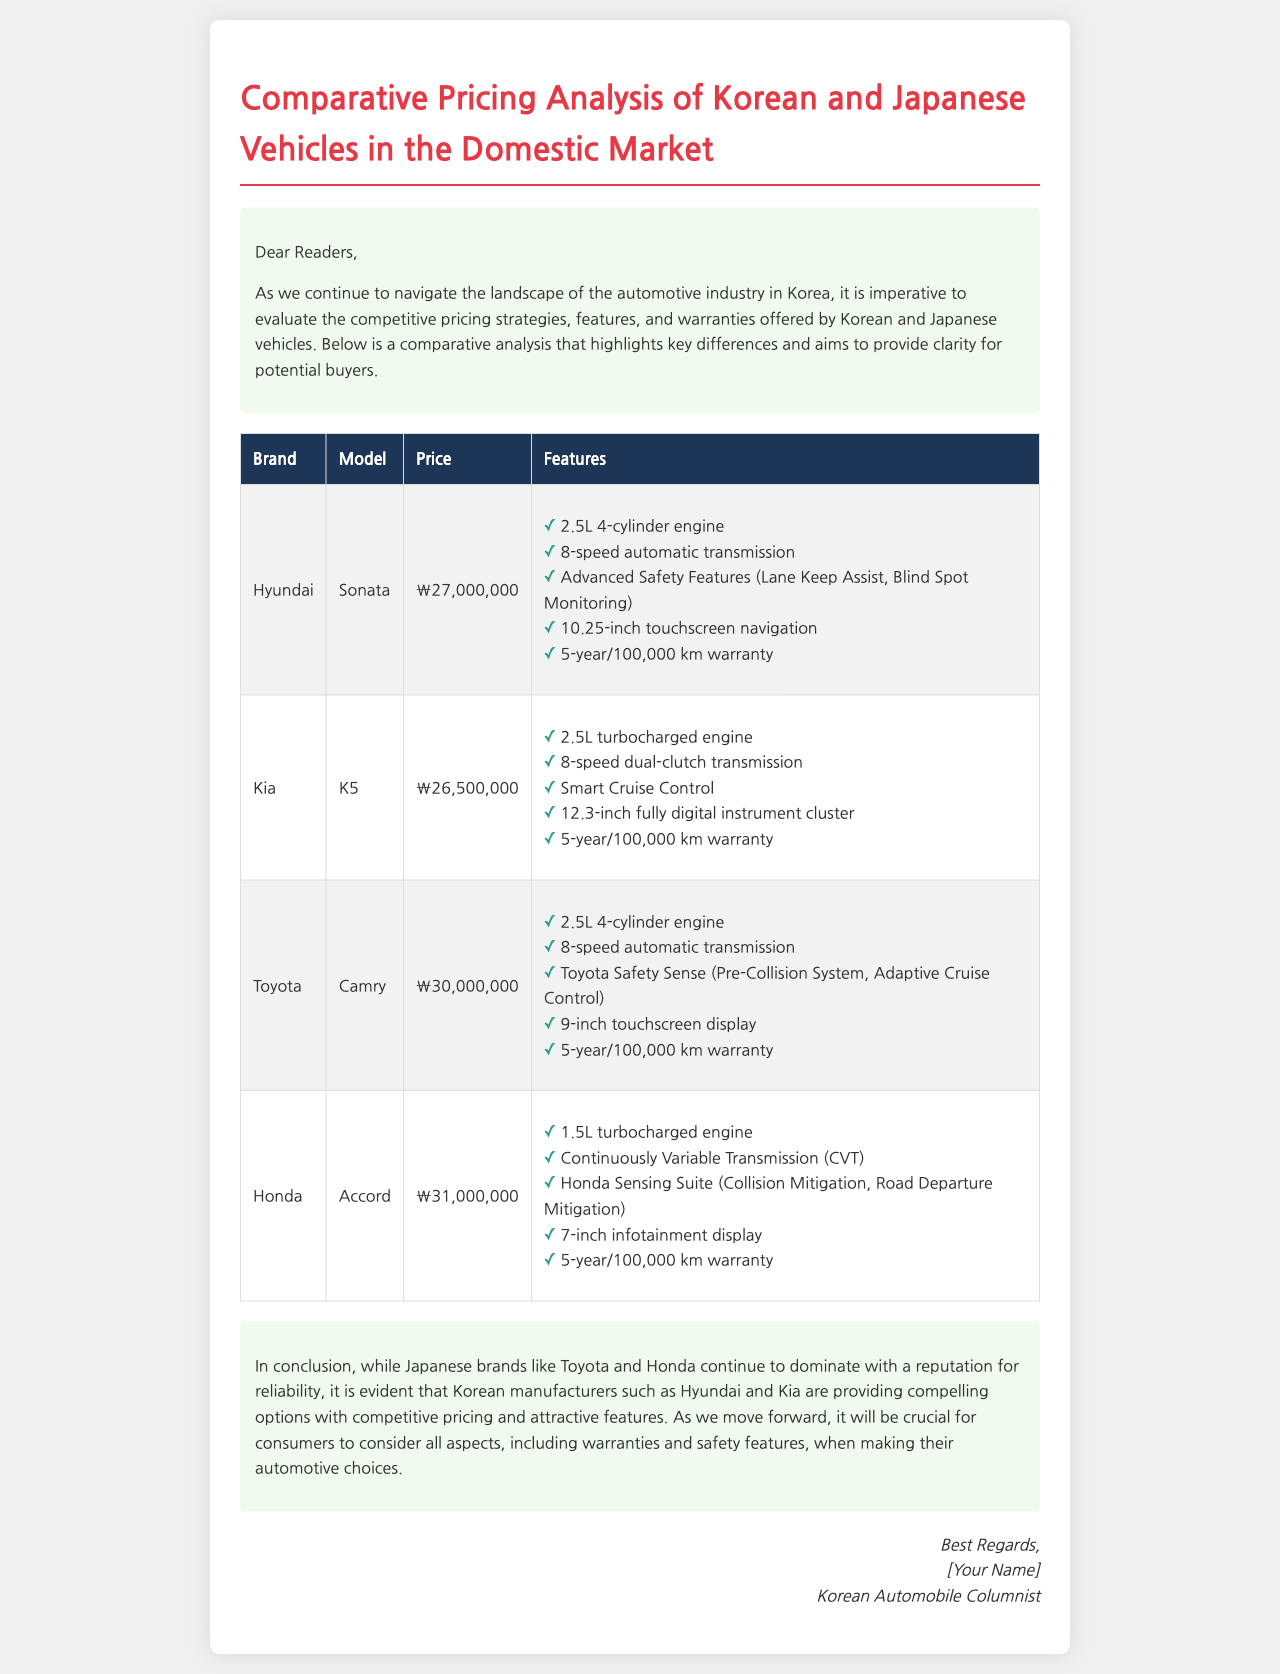what is the price of the Hyundai Sonata? The price of the Hyundai Sonata is stated in the document as ₩27,000,000.
Answer: ₩27,000,000 which engine type is featured in the Kia K5? The document lists the Kia K5 as having a 2.5L turbocharged engine.
Answer: 2.5L turbocharged engine what is one of the safety features listed for the Toyota Camry? The document mentions the Pre-Collision System as one of the safety features for the Toyota Camry.
Answer: Pre-Collision System how long is the warranty for Honda vehicles? The warranty duration for Honda vehicles, as indicated in the document, is 5 years or 100,000 km.
Answer: 5-year/100,000 km which model has the highest listed price? The highest listed price in the document is for the Honda Accord.
Answer: Honda Accord which Korean manufacturer offers the K5? The document states that the K5 is offered by Kia.
Answer: Kia how many features are listed for the Hyundai Sonata? The document lists five features for the Hyundai Sonata.
Answer: Five features what color is the heading of the document? The heading of the document is colored #e63946, a shade of red.
Answer: #e63946 which vehicle is associated with the brand Toyota? The vehicle associated with the brand Toyota in the document is the Camry.
Answer: Camry 